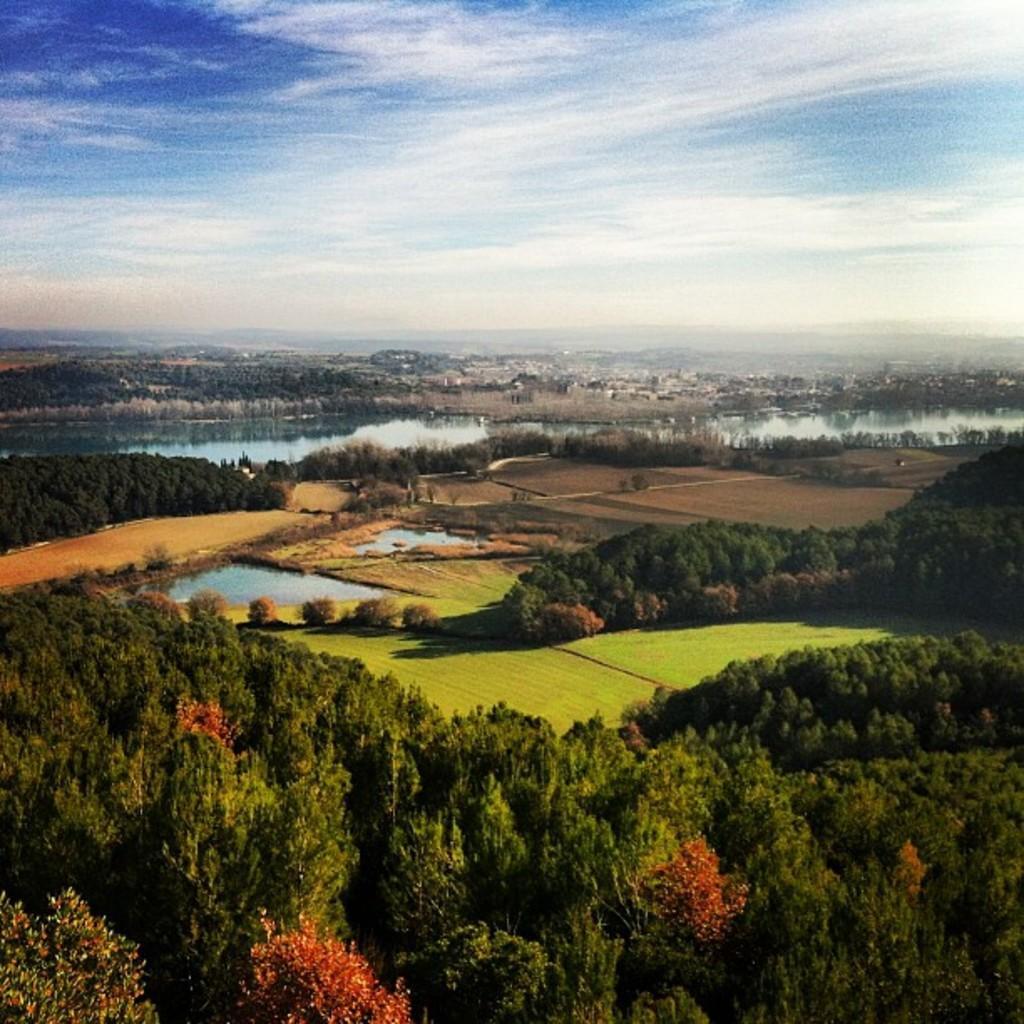Please provide a concise description of this image. In this image I can see few trees, grass and the water. The sky is in blue and white color. 